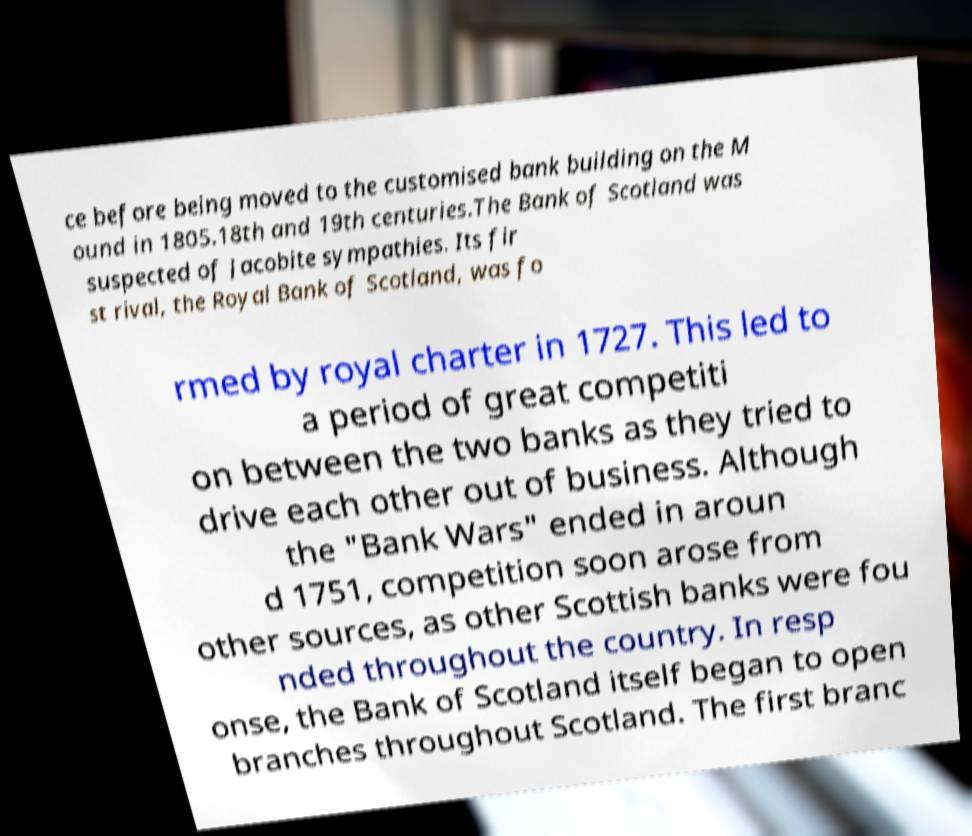Could you extract and type out the text from this image? ce before being moved to the customised bank building on the M ound in 1805.18th and 19th centuries.The Bank of Scotland was suspected of Jacobite sympathies. Its fir st rival, the Royal Bank of Scotland, was fo rmed by royal charter in 1727. This led to a period of great competiti on between the two banks as they tried to drive each other out of business. Although the "Bank Wars" ended in aroun d 1751, competition soon arose from other sources, as other Scottish banks were fou nded throughout the country. In resp onse, the Bank of Scotland itself began to open branches throughout Scotland. The first branc 